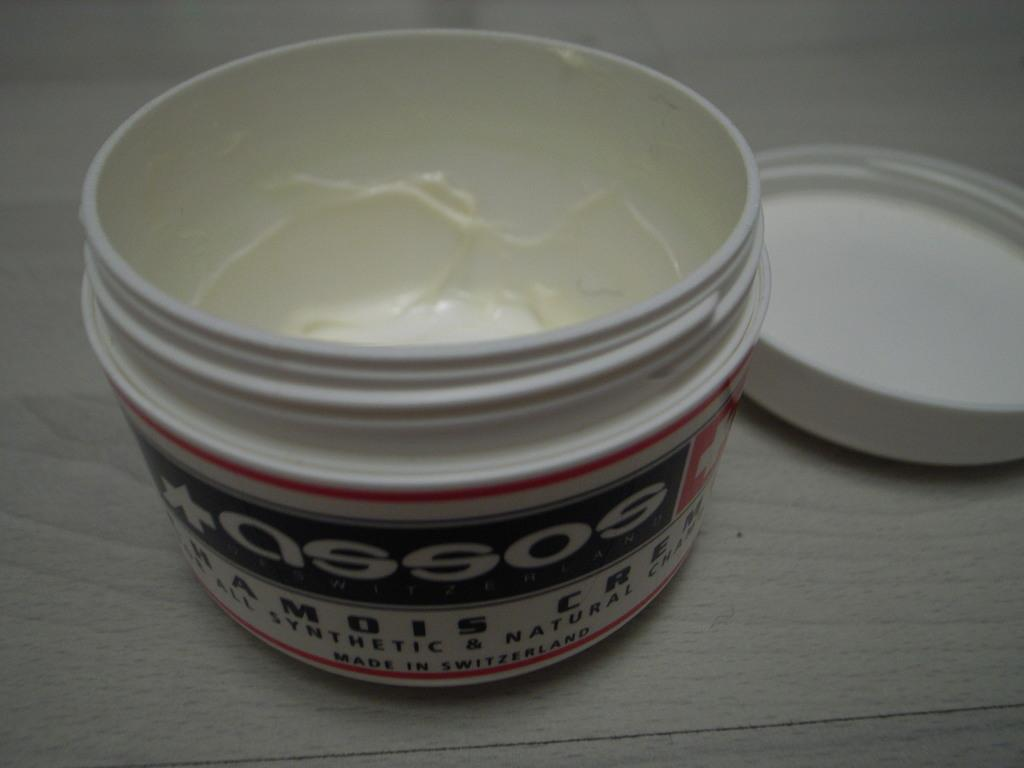<image>
Offer a succinct explanation of the picture presented. a small containter that says 'assos' on it 